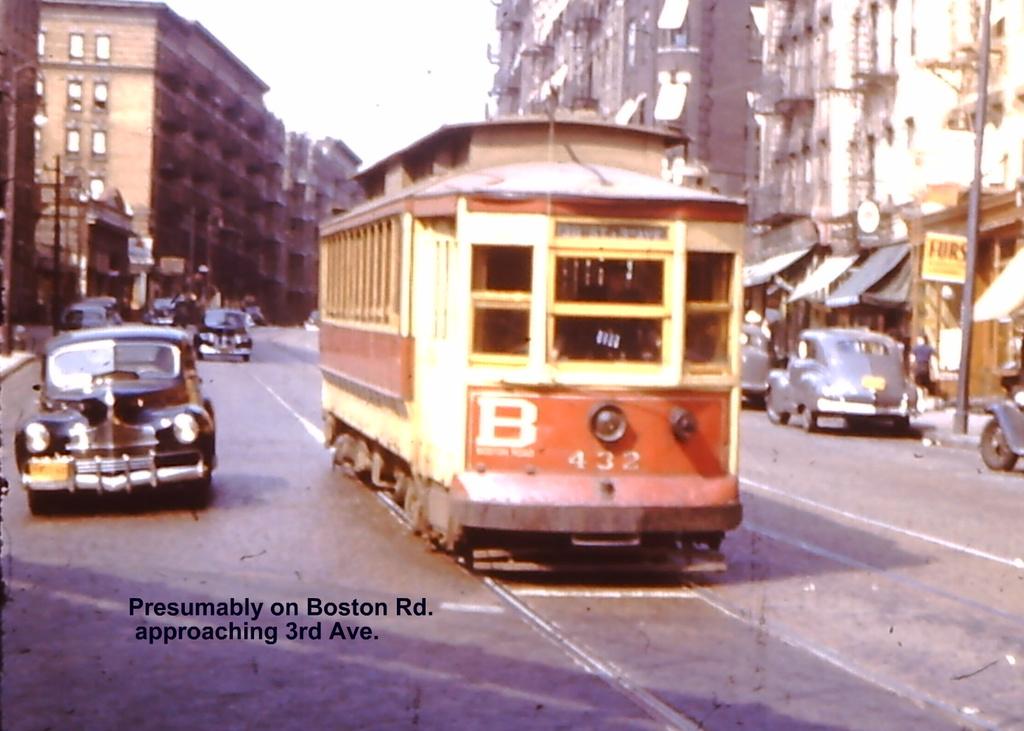What letter is on the front of the trolley?
Your answer should be very brief. B. Is this a school bus/?
Keep it short and to the point. Answering does not require reading text in the image. 